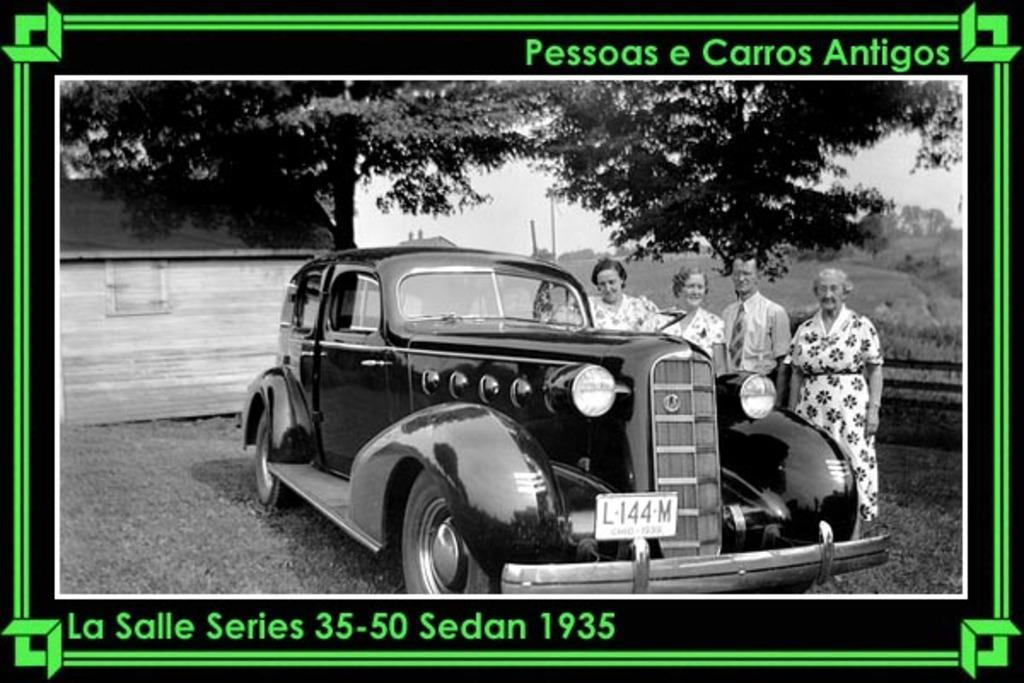Describe this image in one or two sentences. This picture might be a photo frame. This is a black and white image. In this image, on the right side, we can see four people are standing on the grass in front of the car and the car is in the middle. In the background, we can see some trees, plants, pole and a wood wall. At the top, we can see a sky, at the bottom, we can see a grass and a land. 